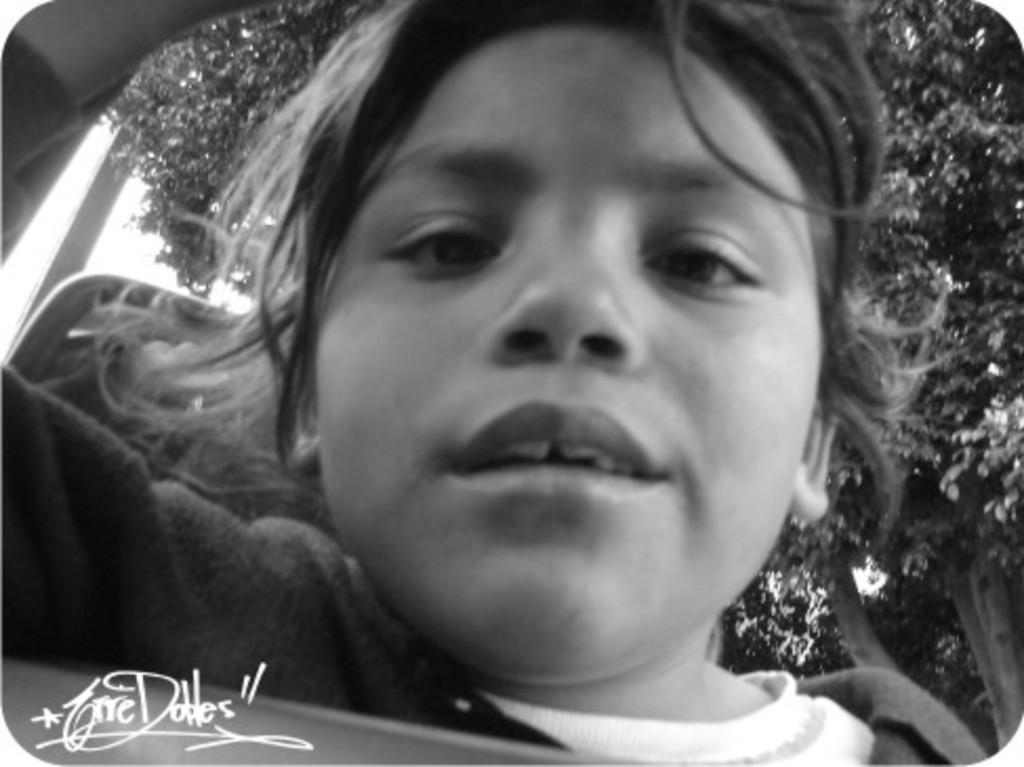What is the color scheme of the image? The image is black and white. Who or what is the main subject in the image? There is a child in the image. What can be seen in the background of the image? There is a tree in the background of the image. Where is the boot located in the image? There is no boot present in the image. What type of needle can be seen in the image? There is no needle present in the image. 